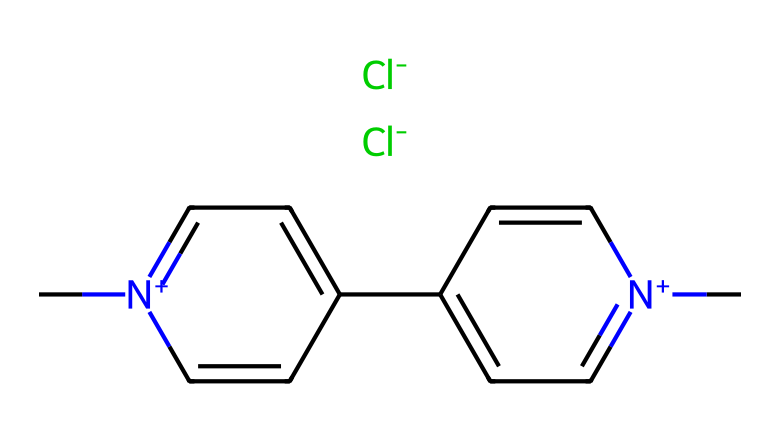What is the molecular formula of paraquat? To derive the molecular formula from the SMILES representation, we identify the number of each type of atom present. This representation indicates the presence of carbon (C), nitrogen (N), and chlorine (Cl) atoms. Counting these atoms reveals the formula: C12H14Cl2N2.
Answer: C12H14Cl2N2 How many nitrogen atoms are in paraquat? Looking at the SMILES, we can identify two nitrogen atoms represented in the structure (the "N" characters). This means paraquat contains 2 nitrogen atoms.
Answer: 2 What type of compound is paraquat? Analyzing the structure, we see the presence of nitrogen-containing heterocycles. Paraquat is classified as a bipyridinium herbicide due to its specific nitrogen configurations.
Answer: bipyridinium herbicide What role do the chlorine atoms play in paraquat? The chlorine atoms in paraquat contribute to its herbicidal activity by enhancing bioavailability and are involved in the reactive properties of the molecule.
Answer: enhance bioavailability How many carbon atoms does paraquat have? By examining the SMILES, we count twelve carbon atoms denoted by the "C" characters in the structure. Therefore, the number of carbon atoms in paraquat is twelve.
Answer: 12 Does paraquat have a positive charge? The presence of "[n+]" in the SMILES indicates that there are positively charged nitrogen atoms in the structure, confirming that paraquat carries a positive charge overall.
Answer: yes 